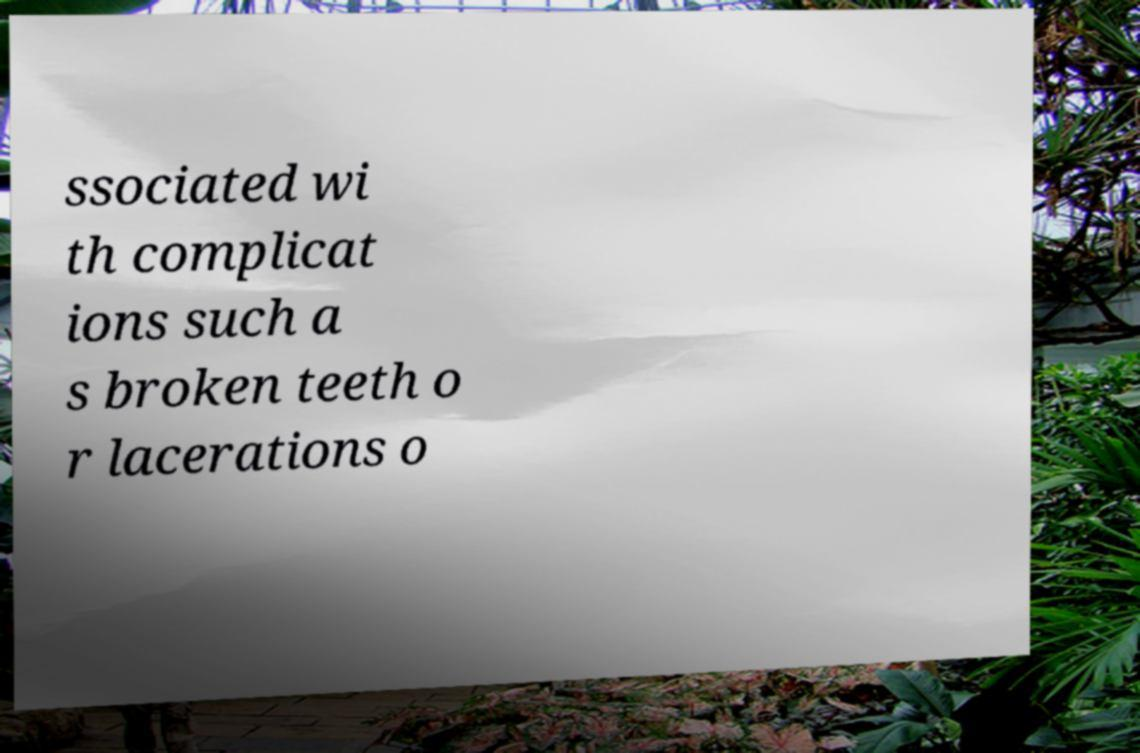What messages or text are displayed in this image? I need them in a readable, typed format. ssociated wi th complicat ions such a s broken teeth o r lacerations o 